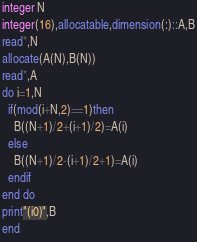<code> <loc_0><loc_0><loc_500><loc_500><_FORTRAN_>integer N
integer(16),allocatable,dimension(:)::A,B
read*,N
allocate(A(N),B(N))
read*,A
do i=1,N
  if(mod(i+N,2)==1)then
    B((N+1)/2+(i+1)/2)=A(i)
  else
    B((N+1)/2-(i+1)/2+1)=A(i)
  endif
end do
print"(i0)",B
end</code> 